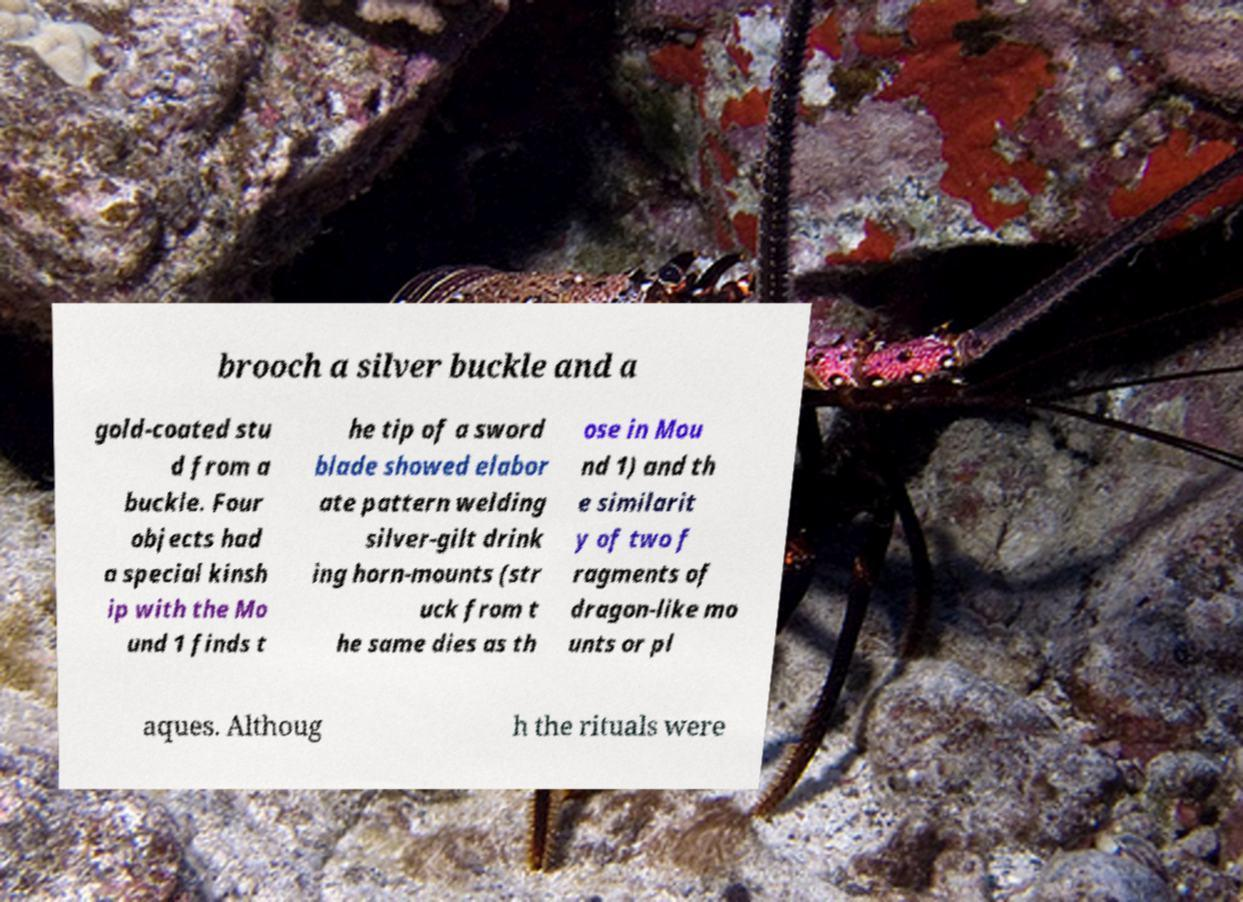Could you extract and type out the text from this image? brooch a silver buckle and a gold-coated stu d from a buckle. Four objects had a special kinsh ip with the Mo und 1 finds t he tip of a sword blade showed elabor ate pattern welding silver-gilt drink ing horn-mounts (str uck from t he same dies as th ose in Mou nd 1) and th e similarit y of two f ragments of dragon-like mo unts or pl aques. Althoug h the rituals were 